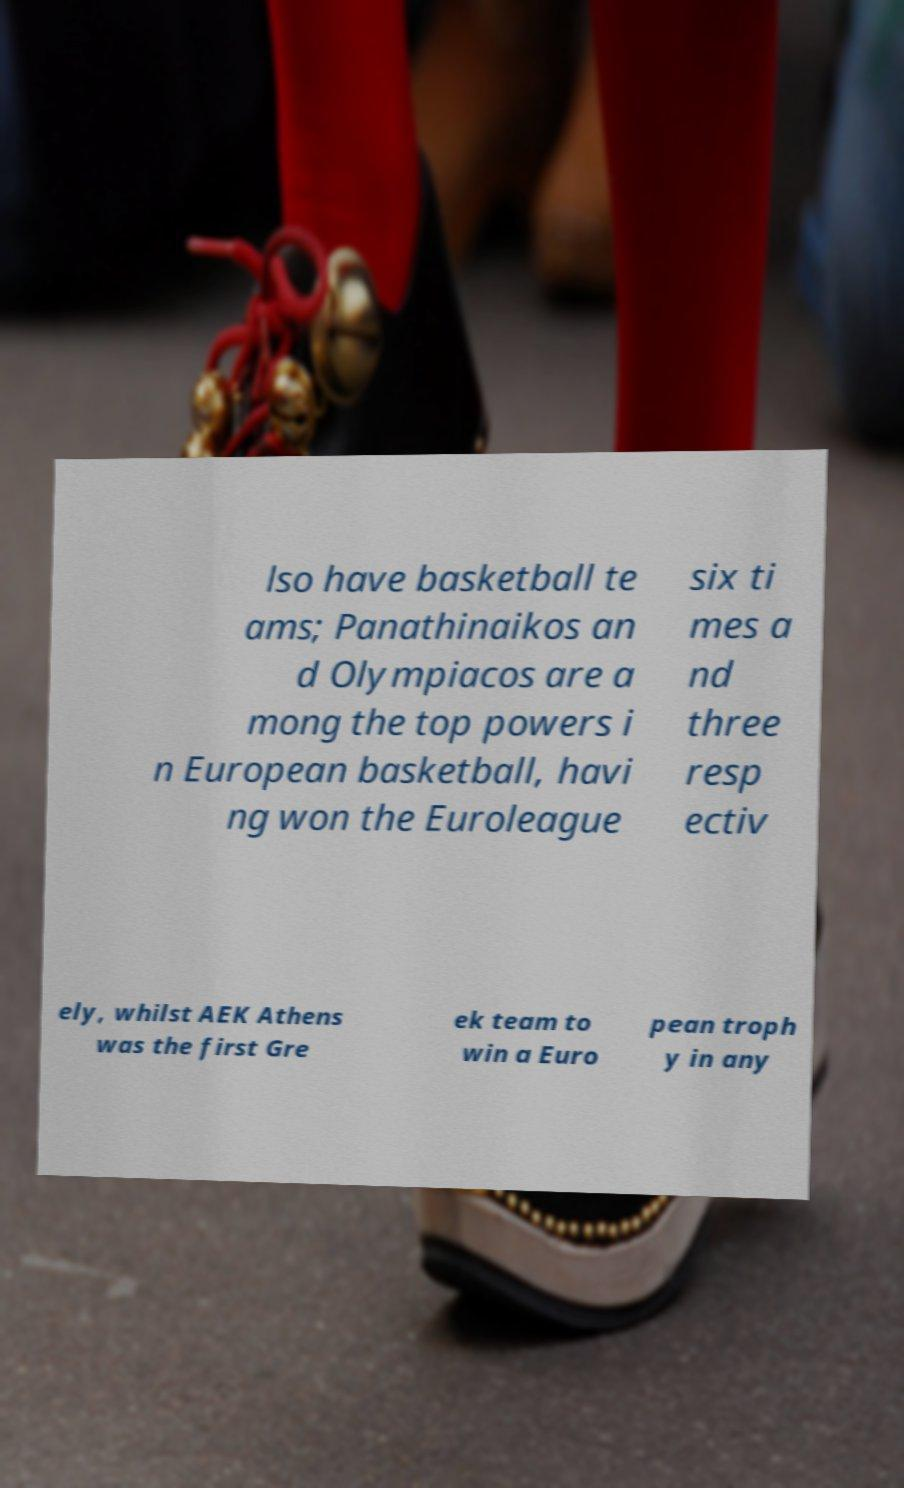Can you accurately transcribe the text from the provided image for me? lso have basketball te ams; Panathinaikos an d Olympiacos are a mong the top powers i n European basketball, havi ng won the Euroleague six ti mes a nd three resp ectiv ely, whilst AEK Athens was the first Gre ek team to win a Euro pean troph y in any 